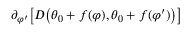<formula> <loc_0><loc_0><loc_500><loc_500>\partial _ { \varphi ^ { \prime } } \left [ D \left ( \theta _ { 0 } + f ( \varphi ) , \theta _ { 0 } + f ( \varphi ^ { \prime } ) \right ) \right ]</formula> 